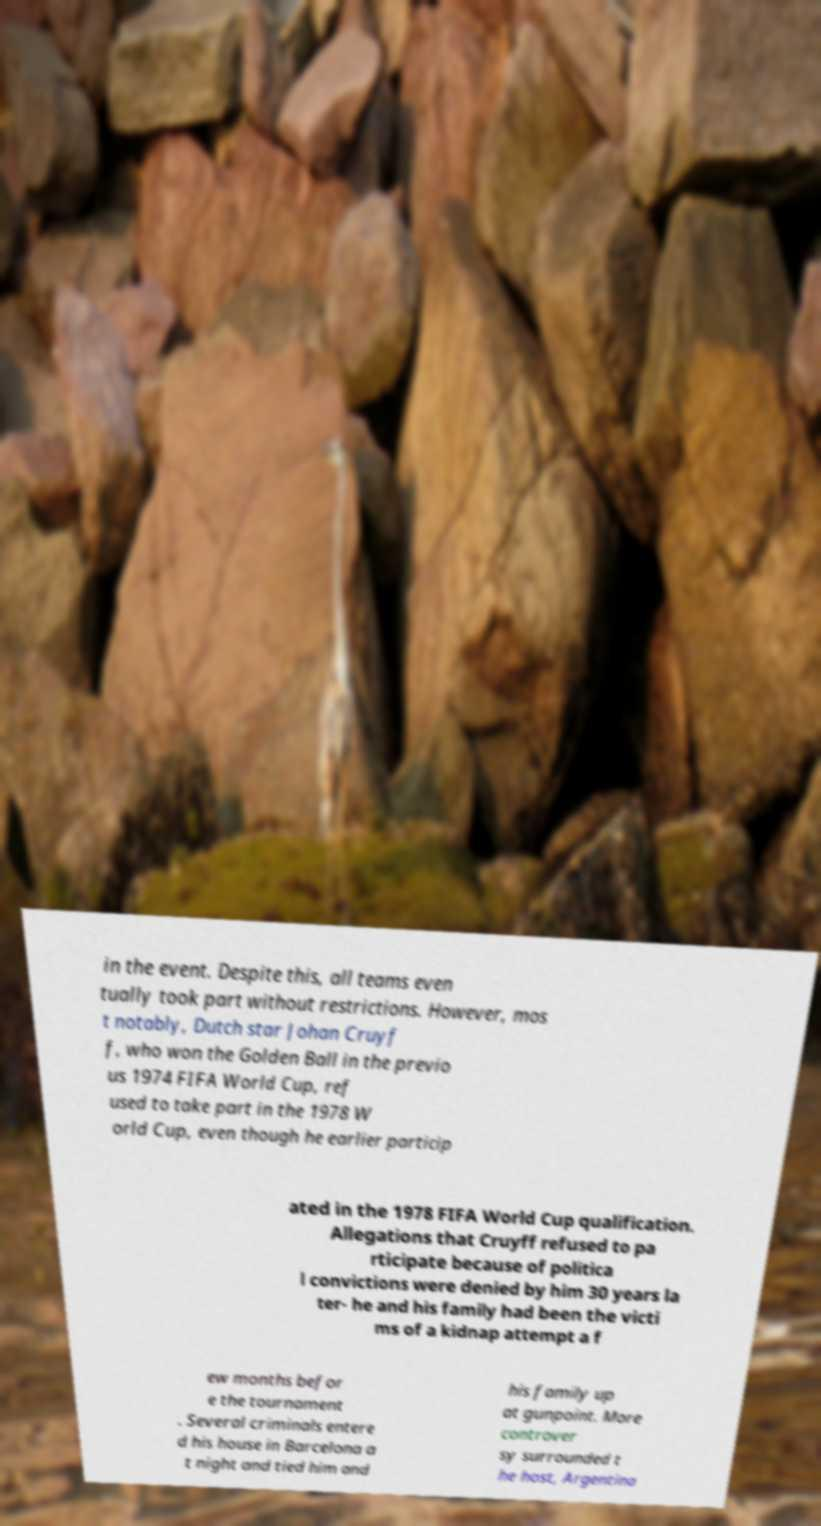What messages or text are displayed in this image? I need them in a readable, typed format. in the event. Despite this, all teams even tually took part without restrictions. However, mos t notably, Dutch star Johan Cruyf f, who won the Golden Ball in the previo us 1974 FIFA World Cup, ref used to take part in the 1978 W orld Cup, even though he earlier particip ated in the 1978 FIFA World Cup qualification. Allegations that Cruyff refused to pa rticipate because of politica l convictions were denied by him 30 years la ter- he and his family had been the victi ms of a kidnap attempt a f ew months befor e the tournament . Several criminals entere d his house in Barcelona a t night and tied him and his family up at gunpoint. More controver sy surrounded t he host, Argentina 